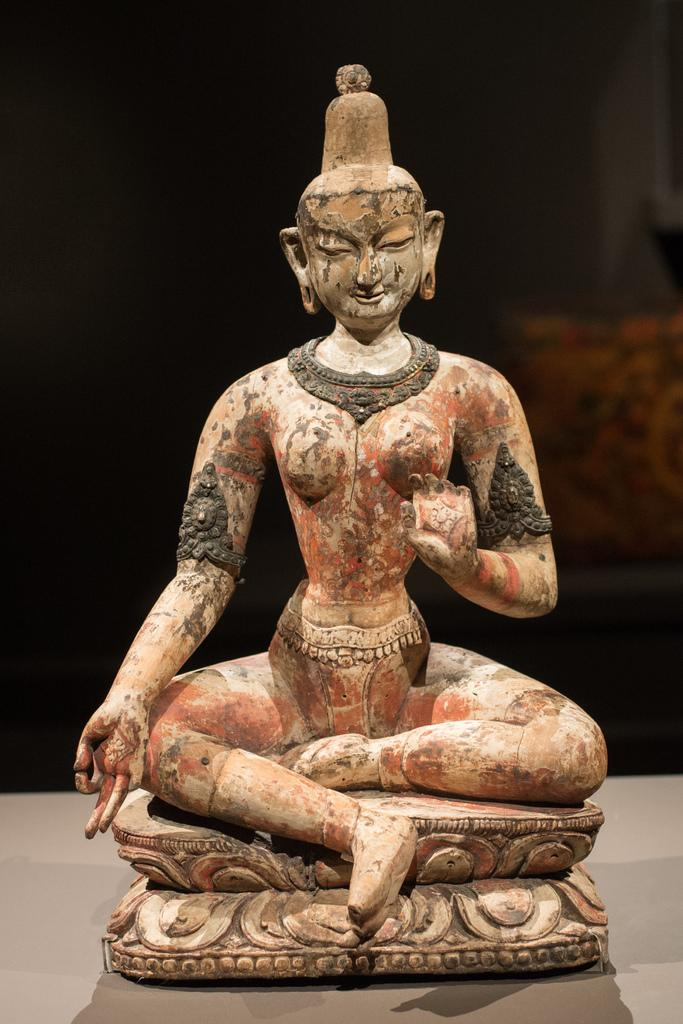What is the main subject of the image? There is a statue in the image. What is the statue standing on? The statue is on a brown color surface. What color is the background of the image? The background of the image is black. What type of pet can be seen wearing a sweater in the image? There is no pet or sweater present in the image; it features a statue on a brown surface with a black background. 